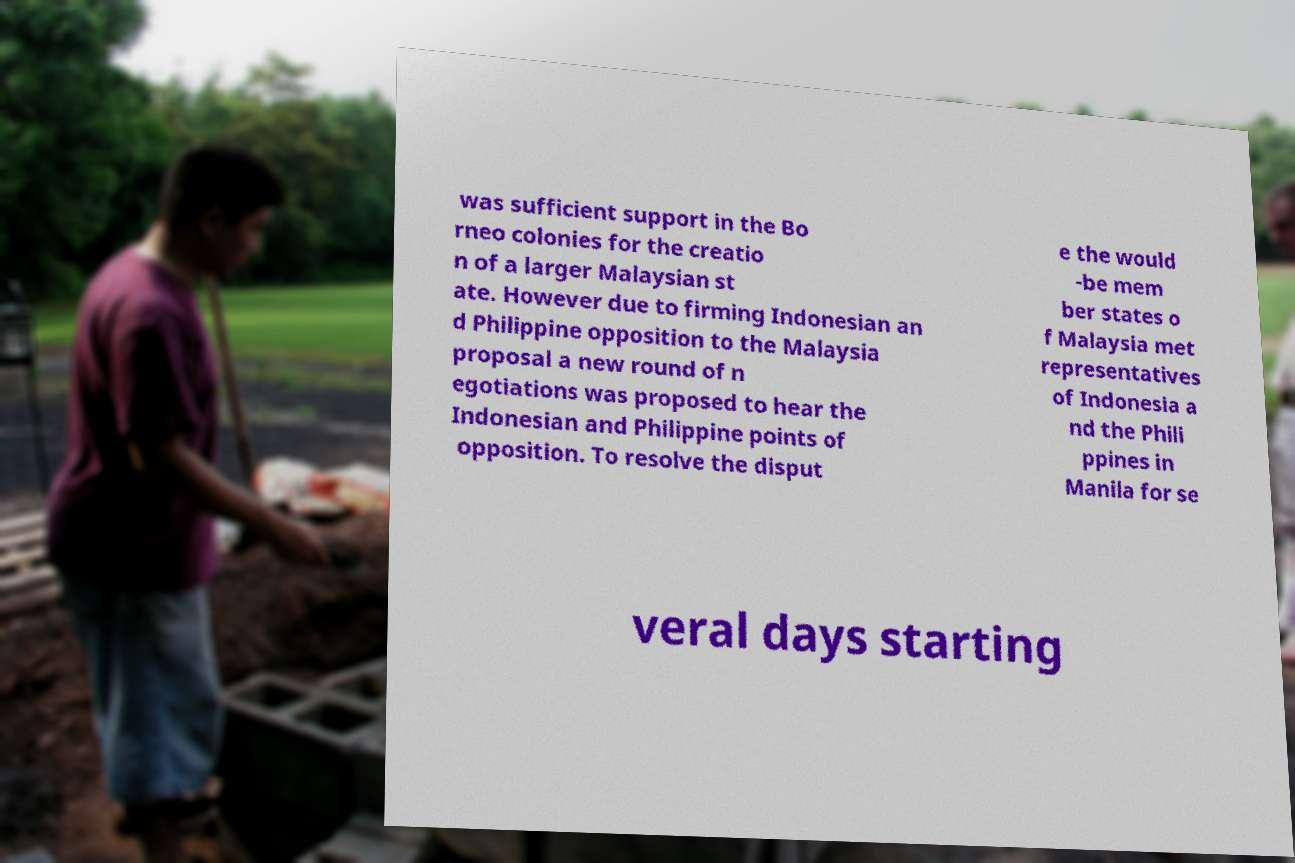I need the written content from this picture converted into text. Can you do that? was sufficient support in the Bo rneo colonies for the creatio n of a larger Malaysian st ate. However due to firming Indonesian an d Philippine opposition to the Malaysia proposal a new round of n egotiations was proposed to hear the Indonesian and Philippine points of opposition. To resolve the disput e the would -be mem ber states o f Malaysia met representatives of Indonesia a nd the Phili ppines in Manila for se veral days starting 